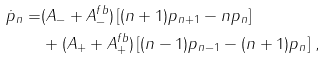<formula> <loc_0><loc_0><loc_500><loc_500>\dot { p } _ { n } = & ( A _ { - } + A _ { - } ^ { f b } ) \left [ ( n + 1 ) p _ { n + 1 } - n p _ { n } \right ] \\ & + ( A _ { + } + A _ { + } ^ { f b } ) \left [ ( n - 1 ) p _ { n - 1 } - ( n + 1 ) p _ { n } \right ] \, ,</formula> 